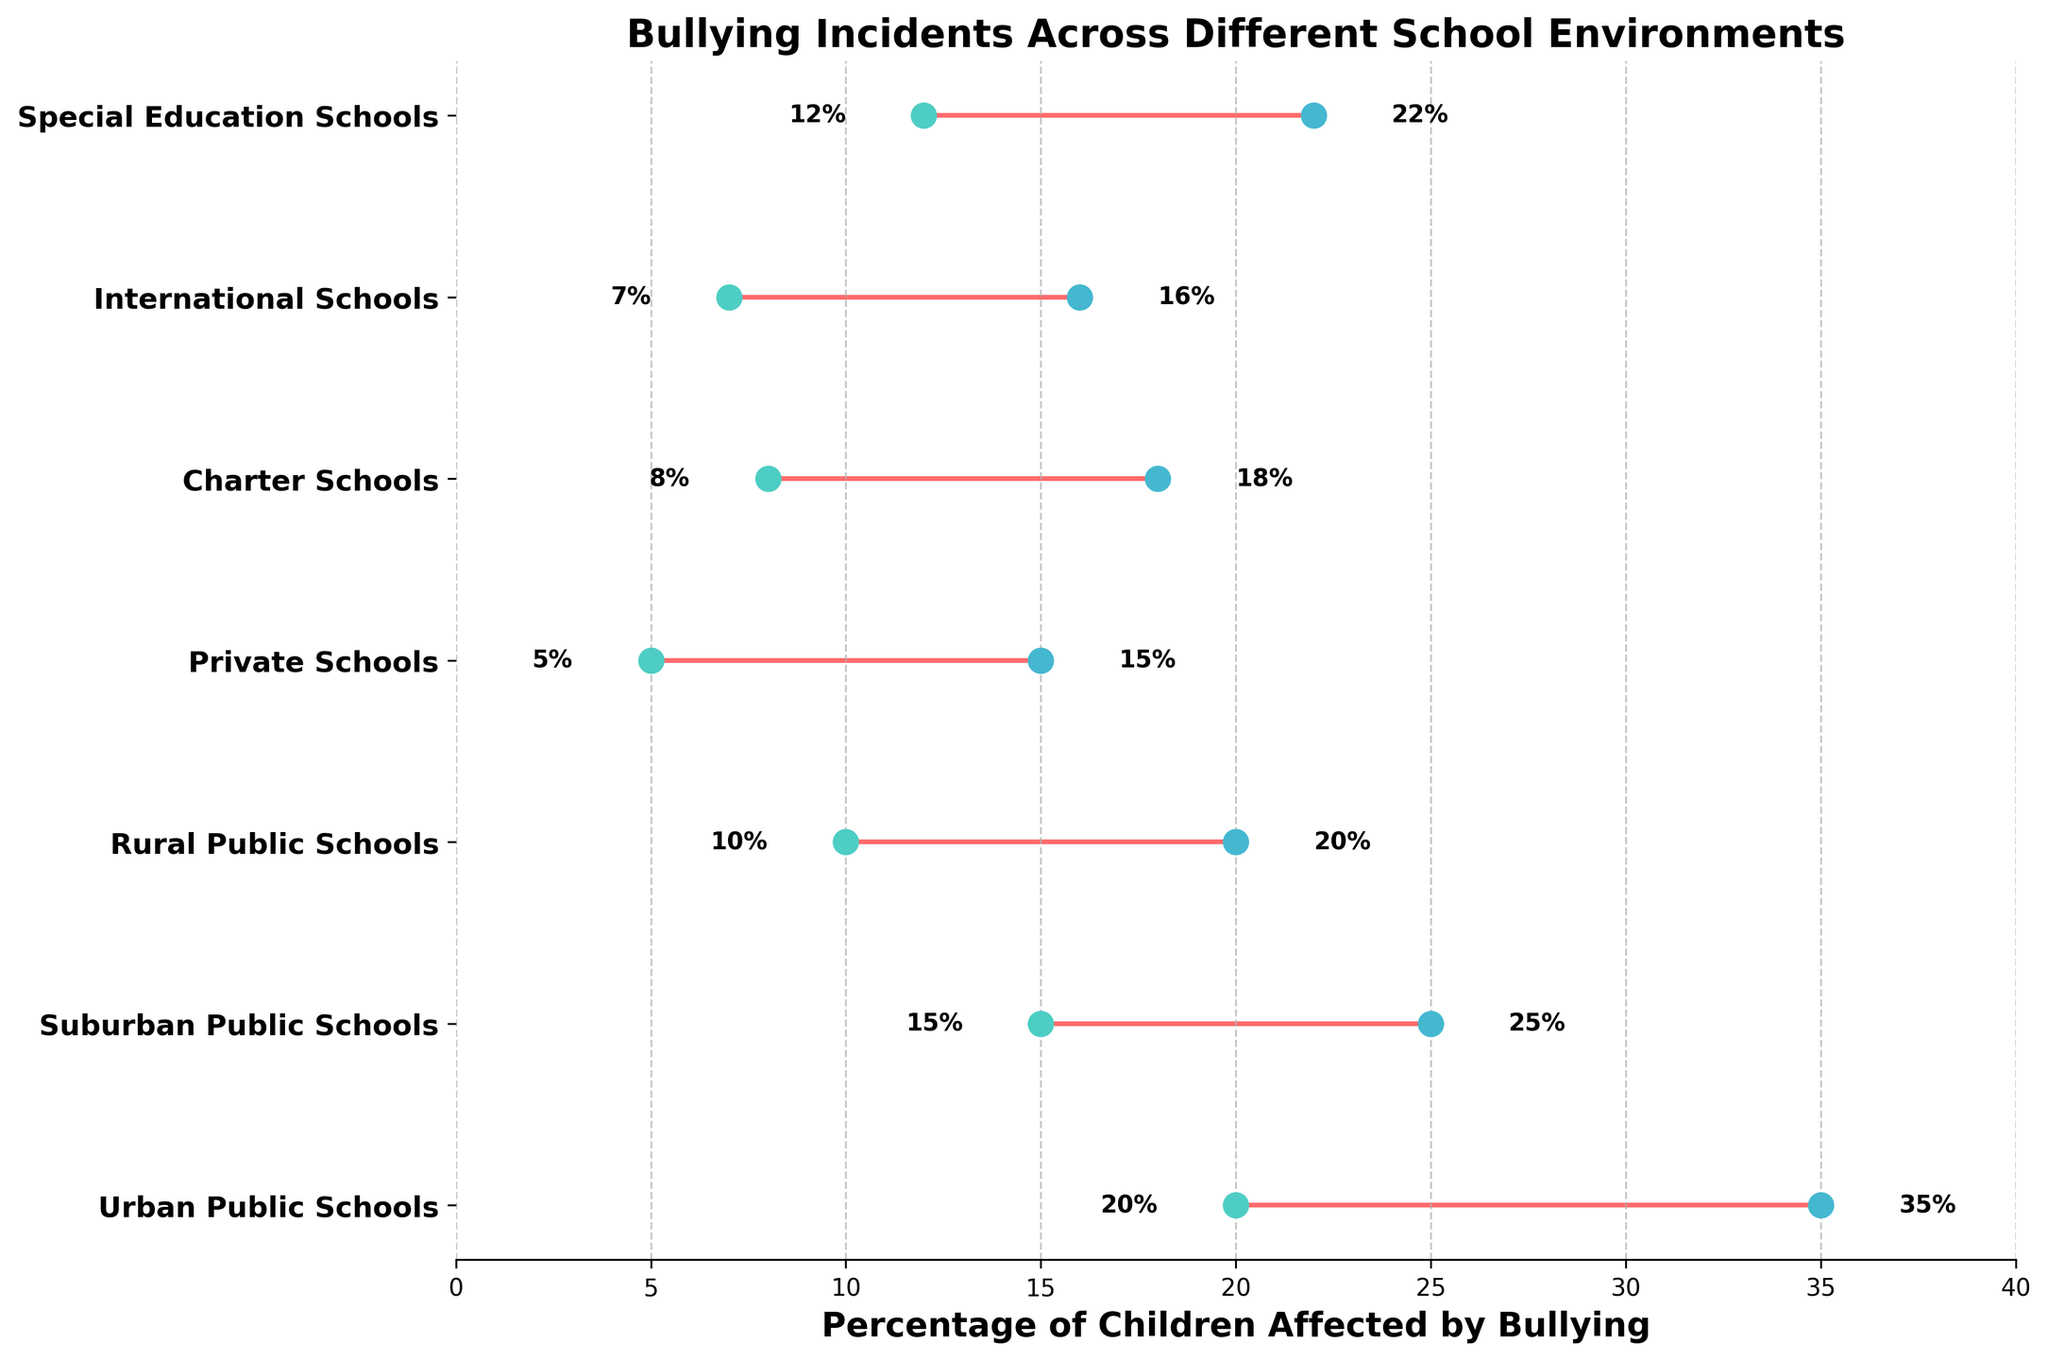How many school environments are included in the plot? Count the number of different school environments listed on the y-axis of the plot.
Answer: 7 What is the title of the plot? Read the text at the top of the plot where the title is typically located.
Answer: Bullying Incidents Across Different School Environments Which school environment has the highest maximum percentage of children affected by bullying? Look for the highest dot on the right side of the x-axis, then identify the corresponding school environment on the y-axis.
Answer: Urban Public Schools What is the range of percentages for children affected by bullying in Suburban Public Schools? Find the Suburban Public Schools label on the y-axis, then note the minimum and maximum percentage values plotted on the x-axis for that label.
Answer: 15-25% Which school environment has the smallest range of percentages for children affected by bullying? Compare the ranges (difference between the maximum and minimum values) of all school environments, and find the smallest one.
Answer: Private Schools How does the range of percentages for Rural Public Schools compare to that of Charter Schools? Calculate the ranges: Rural Public Schools (20% - 10% = 10%) and Charter Schools (18% - 8% = 10%), then compare them.
Answer: Equal What is the average percentage of children affected by bullying in Special Education Schools? Find the minimum and maximum percentages for Special Education Schools, then calculate the average: (12 + 22) / 2.
Answer: 17% Which school environment has a minimum percentage of children affected by bullying below 10%? Look for the dots on the left side of the plot that are below 10%, then identify the corresponding school environments on the y-axis.
Answer: Private Schools, Charter Schools, International Schools What is the difference in the maximum percentage of children affected by bullying between Urban Public Schools and International Schools? Subtract the maximum percentage of International Schools from the maximum percentage of Urban Public Schools: 35% - 16%.
Answer: 19% Is there any school environment where the maximum percentage of children affected by bullying does not exceed 20%? Look for the maximum values on the right side of the plot, and check if any are 20% or lower, then identify corresponding school environments.
Answer: Rural Public Schools, Private Schools, Charter Schools, International Schools, Special Education Schools 